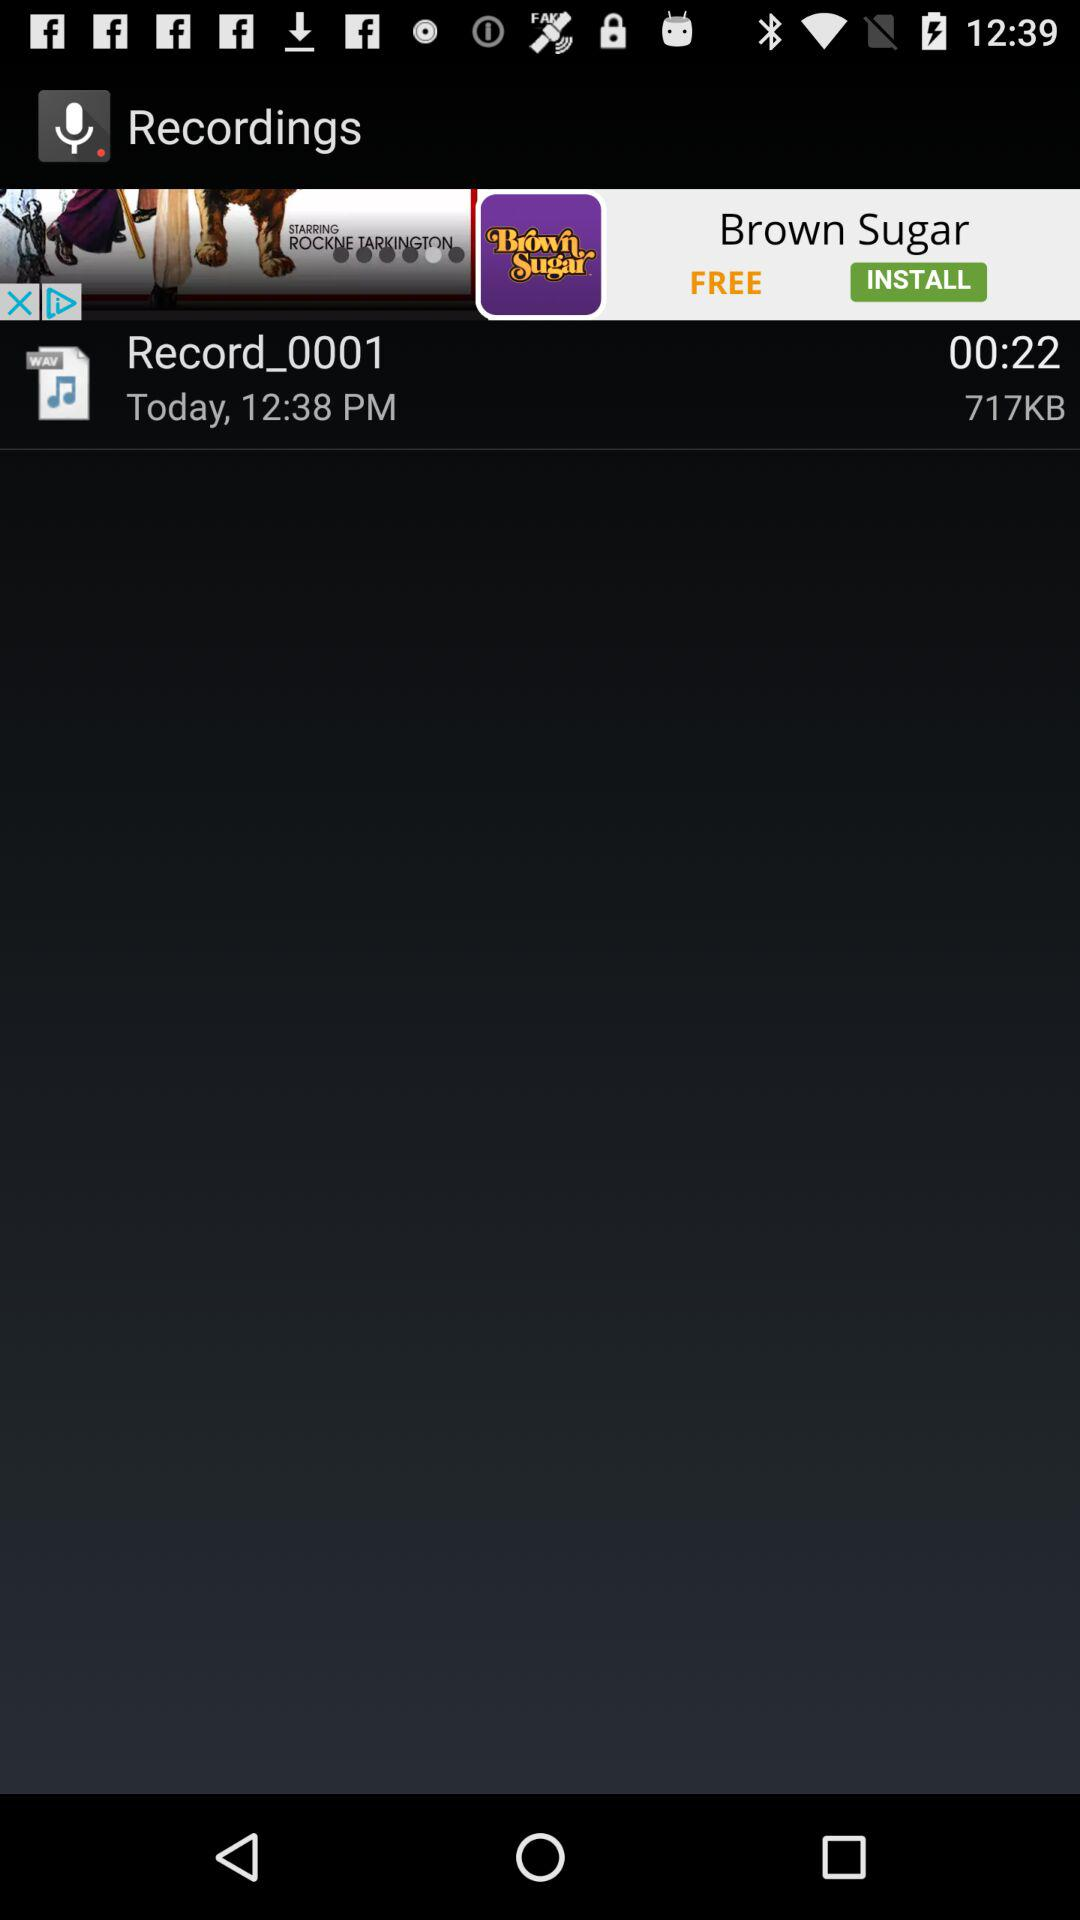What is the time duration of the recording? The time duration of the recording is 00:22. 